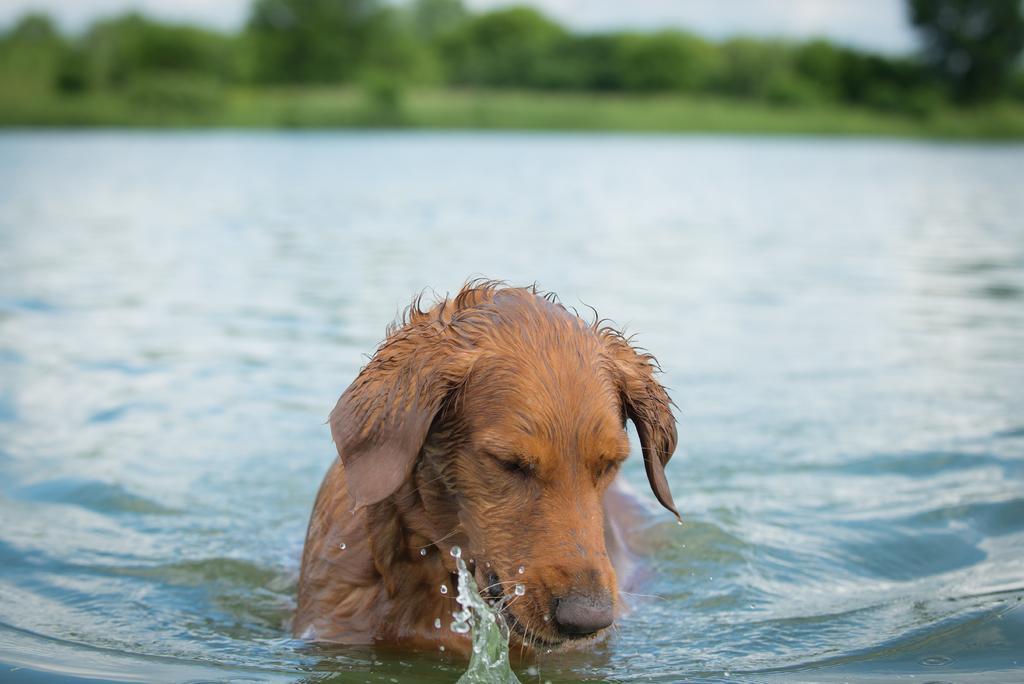Please provide a concise description of this image. In this image I can see a dog in the water and the dog is in brown color, background I can see trees in green color and the sky is in white color. 